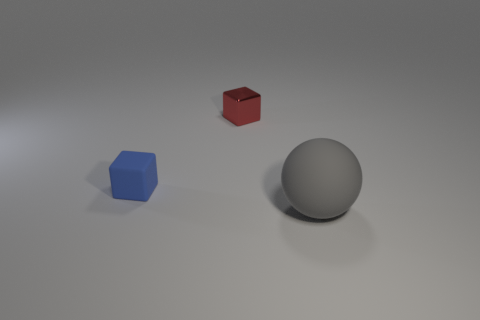What material is the thing in front of the cube that is to the left of the object behind the tiny blue matte thing made of?
Keep it short and to the point. Rubber. Does the tiny cube that is in front of the small red shiny block have the same color as the matte thing that is to the right of the red thing?
Your response must be concise. No. What material is the cube that is behind the matte object to the left of the big gray rubber sphere?
Offer a very short reply. Metal. There is another matte object that is the same size as the red thing; what color is it?
Offer a terse response. Blue. Do the red object and the matte thing to the right of the small blue thing have the same shape?
Provide a short and direct response. No. There is a block that is behind the matte object left of the gray thing; what number of rubber things are right of it?
Give a very brief answer. 1. There is a rubber thing on the right side of the thing on the left side of the tiny metal object; how big is it?
Ensure brevity in your answer.  Large. What is the size of the gray sphere that is the same material as the small blue thing?
Keep it short and to the point. Large. There is a object that is both behind the big gray thing and in front of the metal block; what is its shape?
Your response must be concise. Cube. Are there the same number of things behind the tiny blue matte object and cylinders?
Your response must be concise. No. 